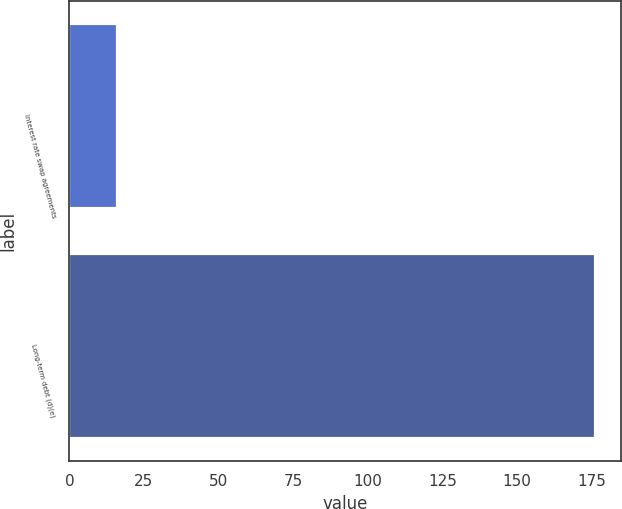Convert chart. <chart><loc_0><loc_0><loc_500><loc_500><bar_chart><fcel>Interest rate swap agreements<fcel>Long-term debt (d)(e)<nl><fcel>16<fcel>176<nl></chart> 